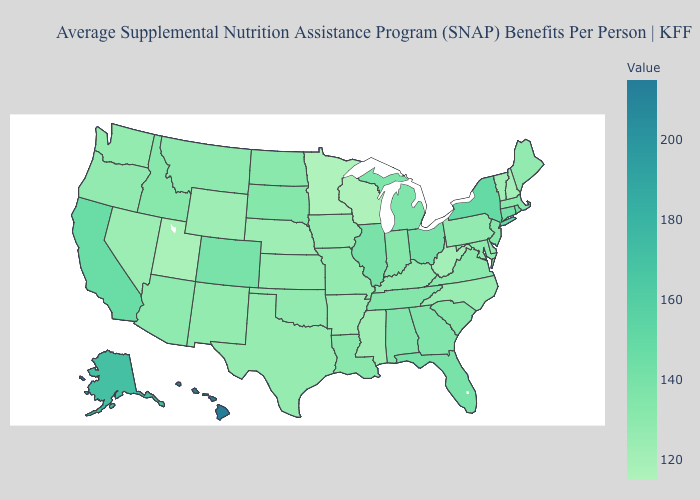Does Virginia have the lowest value in the South?
Give a very brief answer. No. Does Rhode Island have a lower value than New Hampshire?
Quick response, please. No. Does Minnesota have the lowest value in the USA?
Concise answer only. Yes. Among the states that border Tennessee , which have the highest value?
Quick response, please. Alabama, Georgia. 